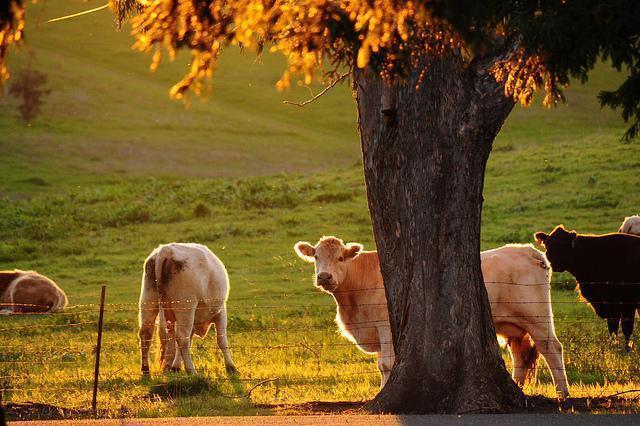What is one of the cows hiding behind?
Indicate the correct choice and explain in the format: 'Answer: answer
Rationale: rationale.'
Options: Airplane, truck, tree, elephant. Answer: tree.
Rationale: The cow is behind a tree. 